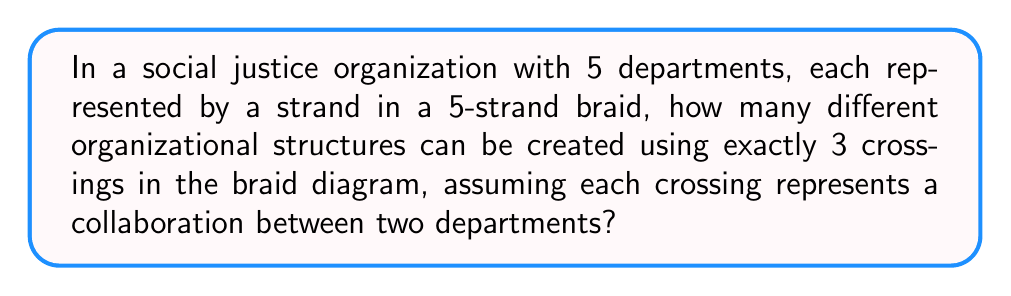Could you help me with this problem? To solve this problem, we'll use concepts from braid theory and combinatorics:

1) In a 5-strand braid, each crossing involves 2 adjacent strands out of the 5 strands.

2) For each crossing, we have 4 possible pairs of adjacent strands: (1,2), (2,3), (3,4), or (4,5).

3) We need to choose 3 crossings out of these 4 possibilities, with repetition allowed and order matters.

4) This scenario can be modeled as a combination with repetition problem, where the order matters.

5) The formula for this is:
   $$n^r$$
   where $n$ is the number of types of crossings (4 in this case) and $r$ is the number of crossings we're using (3).

6) Plugging in our values:
   $$4^3 = 64$$

7) Therefore, there are 64 different ways to arrange 3 crossings in a 5-strand braid.

This result represents the number of different organizational structures that can be created, where each structure shows a unique pattern of collaboration between departments.
Answer: 64 